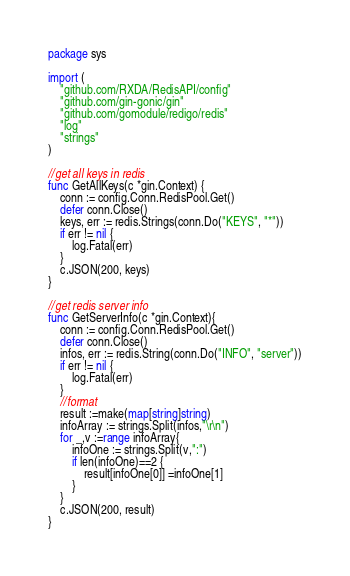Convert code to text. <code><loc_0><loc_0><loc_500><loc_500><_Go_>package sys

import (
	"github.com/RXDA/RedisAPI/config"
	"github.com/gin-gonic/gin"
	"github.com/gomodule/redigo/redis"
	"log"
	"strings"
)

//get all keys in redis
func GetAllKeys(c *gin.Context) {
	conn := config.Conn.RedisPool.Get()
	defer conn.Close()
	keys, err := redis.Strings(conn.Do("KEYS", "*"))
	if err != nil {
		log.Fatal(err)
	}
	c.JSON(200, keys)
}

//get redis server info
func GetServerInfo(c *gin.Context){
	conn := config.Conn.RedisPool.Get()
	defer conn.Close()
	infos, err := redis.String(conn.Do("INFO", "server"))
	if err != nil {
		log.Fatal(err)
	}
	//format
	result :=make(map[string]string)
	infoArray := strings.Split(infos,"\r\n")
	for _,v :=range infoArray{
		infoOne := strings.Split(v,":")
		if len(infoOne)==2 {
			result[infoOne[0]] =infoOne[1]
		}
	}
	c.JSON(200, result)
}</code> 